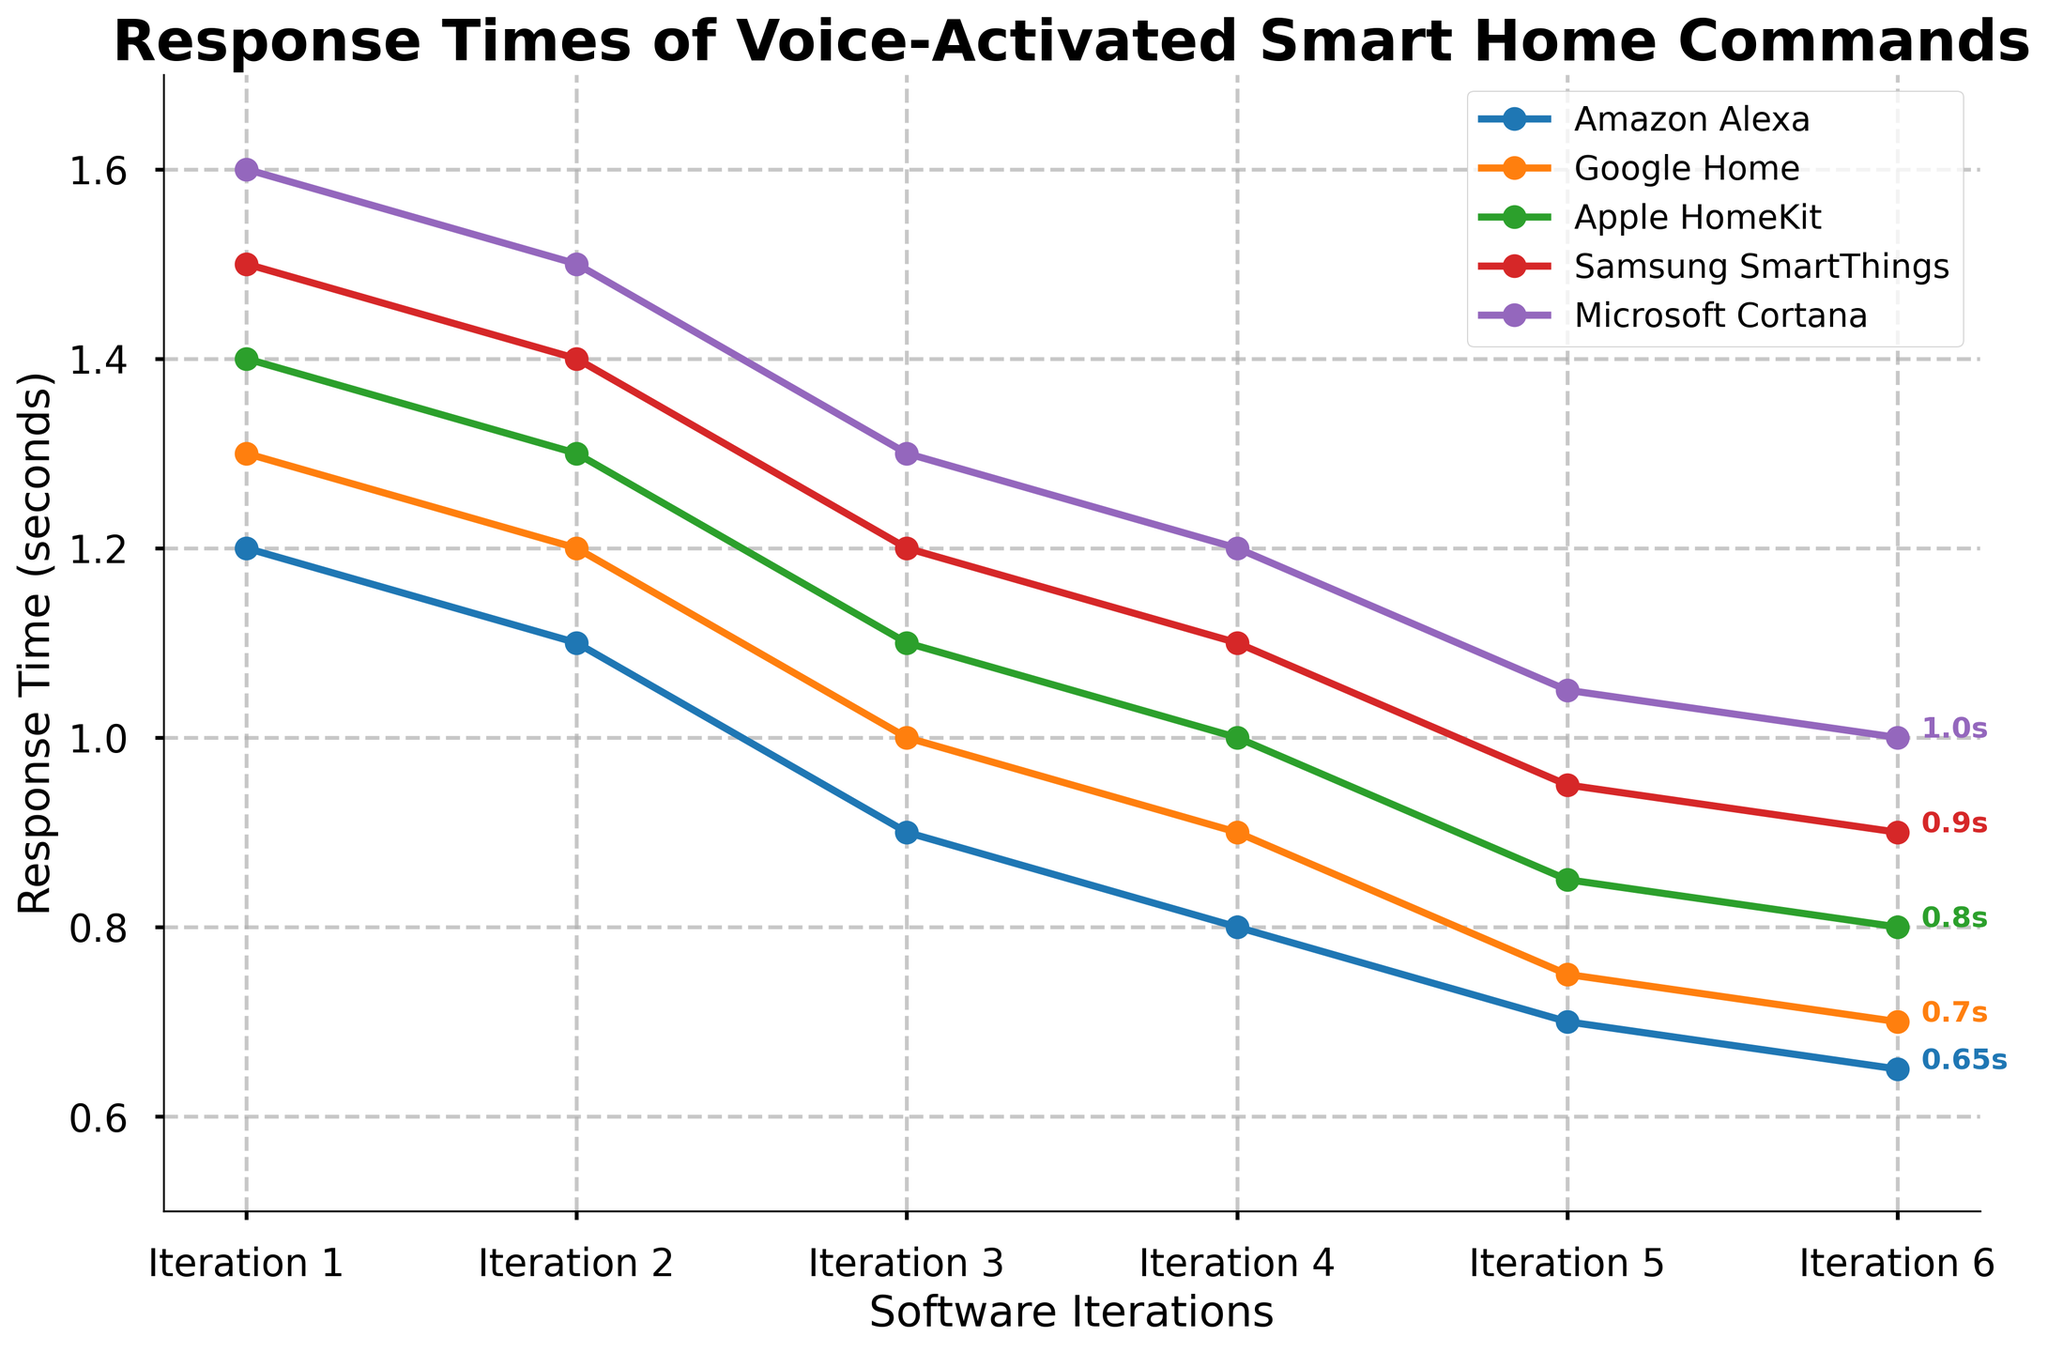Which platform experienced the greatest reduction in response time from Iteration 1 to Iteration 6? Calculate the reduction for each platform: Amazon Alexa (1.2 - 0.65), Google Home (1.3 - 0.7), Apple HomeKit (1.4 - 0.8), Samsung SmartThings (1.5 - 0.9), Microsoft Cortana (1.6 - 1.0). Amazon Alexa experienced the greatest reduction.
Answer: Amazon Alexa Which platform has the highest response time at Iteration 6? Check the response times at Iteration 6: Amazon Alexa (0.65), Google Home (0.7), Apple HomeKit (0.8), Samsung SmartThings (0.9), Microsoft Cortana (1.0). Microsoft Cortana has the highest response time.
Answer: Microsoft Cortana What is the average response time of Google Home across all iterations? Sum the response times for Google Home (1.3 + 1.2 + 1.0 + 0.9 + 0.75 + 0.7) = 5.85, then divide by the number of iterations (6). The average is 5.85 / 6 = 0.975 seconds.
Answer: 0.975 seconds How many iterations did it take for Apple HomeKit to reach a response time below 1 second? Review the response times for Apple HomeKit across iterations and find the first instance below 1 second: Iteration 4 has a response time of 1.0 which is still not below 1 second, Iteration 5 shows 0.85. It took 5 iterations.
Answer: 5 iterations Which platform showed a consistent decrease in response time over all iterations? Check for each platform if their response time consistently decreases from one iteration to the next: Amazon Alexa, Google Home, Apple HomeKit, Samsung SmartThings, and Microsoft Cortana all show a consistent decrease.
Answer: All platforms In which iteration did Samsung SmartThings have the same response time as Google Home's Iteration 5? Check the response time of Google Home at Iteration 5 (0.75) and find the corresponding iteration for Samsung SmartThings with the same response time, which is Iteration 5 as well.
Answer: Iteration 5 What is the overall trend of the response times for all platforms from iteration 1 to iteration 6? All platforms show a downward trend in their response times from iteration 1 to iteration 6. This indicates improvement in response times across iterations.
Answer: Downward trend Compare the response times of Amazon Alexa and Microsoft Cortana at Iteration 3. Which one is faster and by how much? Check the response times at Iteration 3: Amazon Alexa is 0.9 seconds, and Microsoft Cortana is 1.3 seconds. Difference is 1.3 - 0.9 = 0.4 seconds. Amazon Alexa is faster by 0.4 seconds.
Answer: Amazon Alexa by 0.4 seconds 